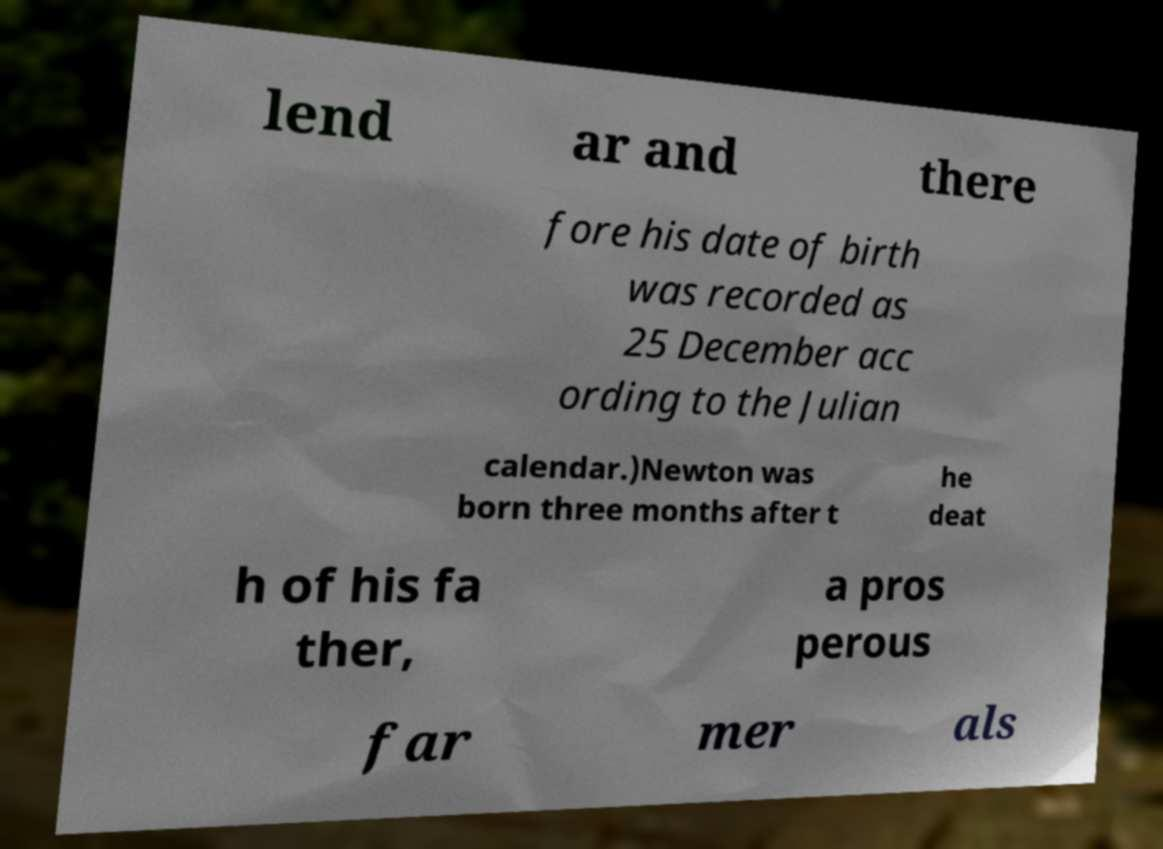Please read and relay the text visible in this image. What does it say? lend ar and there fore his date of birth was recorded as 25 December acc ording to the Julian calendar.)Newton was born three months after t he deat h of his fa ther, a pros perous far mer als 